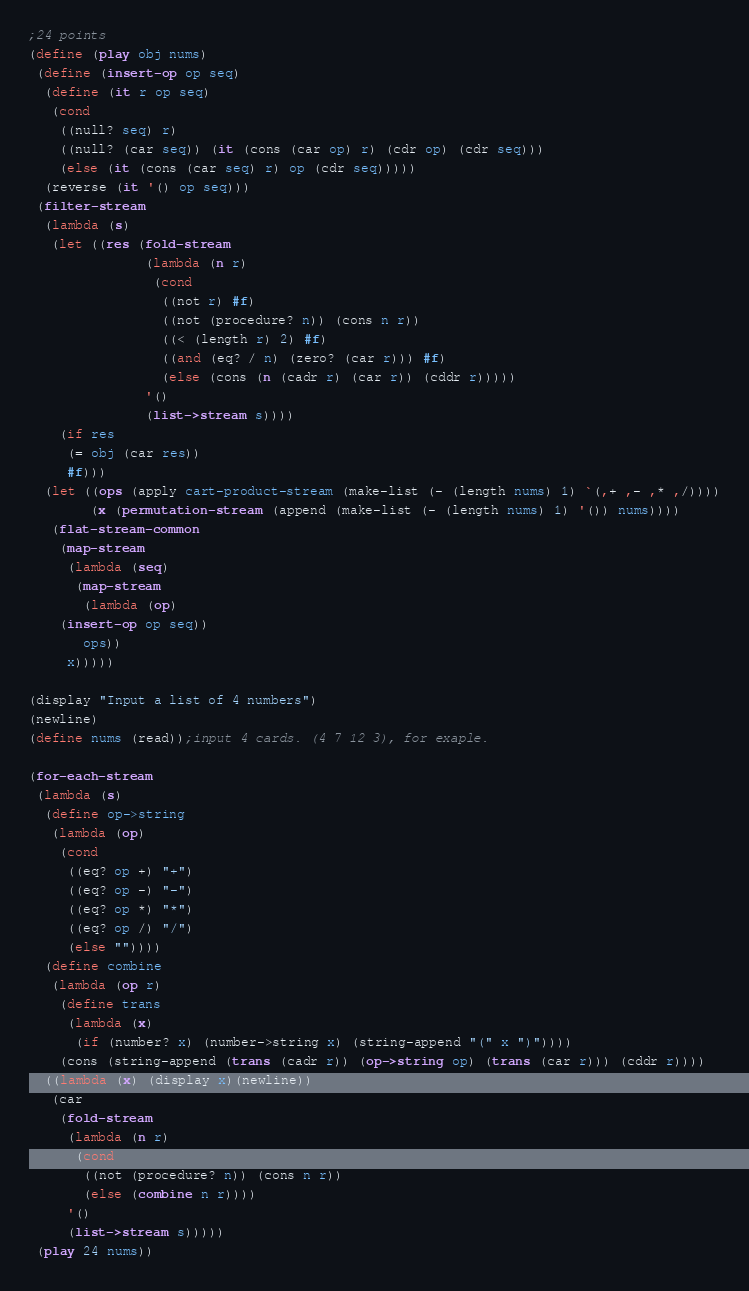<code> <loc_0><loc_0><loc_500><loc_500><_Scheme_>;24 points
(define (play obj nums)
 (define (insert-op op seq)
  (define (it r op seq)
   (cond
    ((null? seq) r)
    ((null? (car seq)) (it (cons (car op) r) (cdr op) (cdr seq)))
    (else (it (cons (car seq) r) op (cdr seq)))))
  (reverse (it '() op seq)))
 (filter-stream
  (lambda (s)
   (let ((res (fold-stream
               (lambda (n r)
                (cond
                 ((not r) #f)
                 ((not (procedure? n)) (cons n r))
                 ((< (length r) 2) #f)
                 ((and (eq? / n) (zero? (car r))) #f)
                 (else (cons (n (cadr r) (car r)) (cddr r)))))
               '()
               (list->stream s))))
    (if res
     (= obj (car res))
     #f)))
  (let ((ops (apply cart-product-stream (make-list (- (length nums) 1) `(,+ ,- ,* ,/))))
        (x (permutation-stream (append (make-list (- (length nums) 1) '()) nums))))
   (flat-stream-common
    (map-stream
     (lambda (seq)
      (map-stream
       (lambda (op)
	(insert-op op seq))
       ops))
     x)))))

(display "Input a list of 4 numbers")
(newline)
(define nums (read));input 4 cards. (4 7 12 3), for exaple.

(for-each-stream
 (lambda (s)
  (define op->string
   (lambda (op)
    (cond
     ((eq? op +) "+")
     ((eq? op -) "-")
     ((eq? op *) "*")
     ((eq? op /) "/")
     (else ""))))
  (define combine
   (lambda (op r)
    (define trans
     (lambda (x)
      (if (number? x) (number->string x) (string-append "(" x ")"))))
    (cons (string-append (trans (cadr r)) (op->string op) (trans (car r))) (cddr r))))
  ((lambda (x) (display x)(newline))
   (car
    (fold-stream
     (lambda (n r)
      (cond
       ((not (procedure? n)) (cons n r))
       (else (combine n r))))
     '()
     (list->stream s)))))
 (play 24 nums))

</code> 